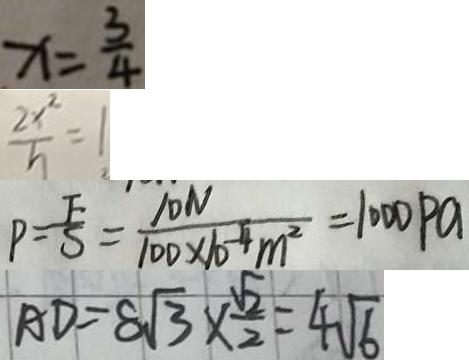Convert formula to latex. <formula><loc_0><loc_0><loc_500><loc_500>x = \frac { 3 } { 4 } 
 \frac { 2 x ^ { 2 } } { h } = 1 
 P = \frac { F } { S } = \frac { 1 0 N } { 1 0 0 \times 1 0 ^ { - 4 } m ^ { 2 } } = 1 0 0 0 P a 
 A D = 8 \sqrt { 3 } \times \frac { \sqrt { 2 } } { 2 } = 4 \sqrt { 6 }</formula> 